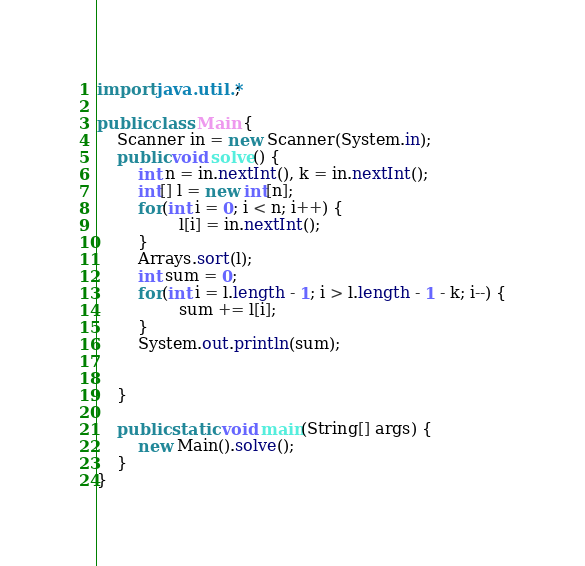Convert code to text. <code><loc_0><loc_0><loc_500><loc_500><_Java_>import java.util.*;

public class Main {
    Scanner in = new Scanner(System.in);
    public void solve() {
        int n = in.nextInt(), k = in.nextInt();
        int[] l = new int[n];
        for(int i = 0; i < n; i++) {
        		l[i] = in.nextInt();
        }
        Arrays.sort(l);
        int sum = 0;
        for(int i = l.length - 1; i > l.length - 1 - k; i--) {
        		sum += l[i];
        }
        System.out.println(sum);
   

    }

    public static void main(String[] args) {
        new Main().solve();
    }
}</code> 